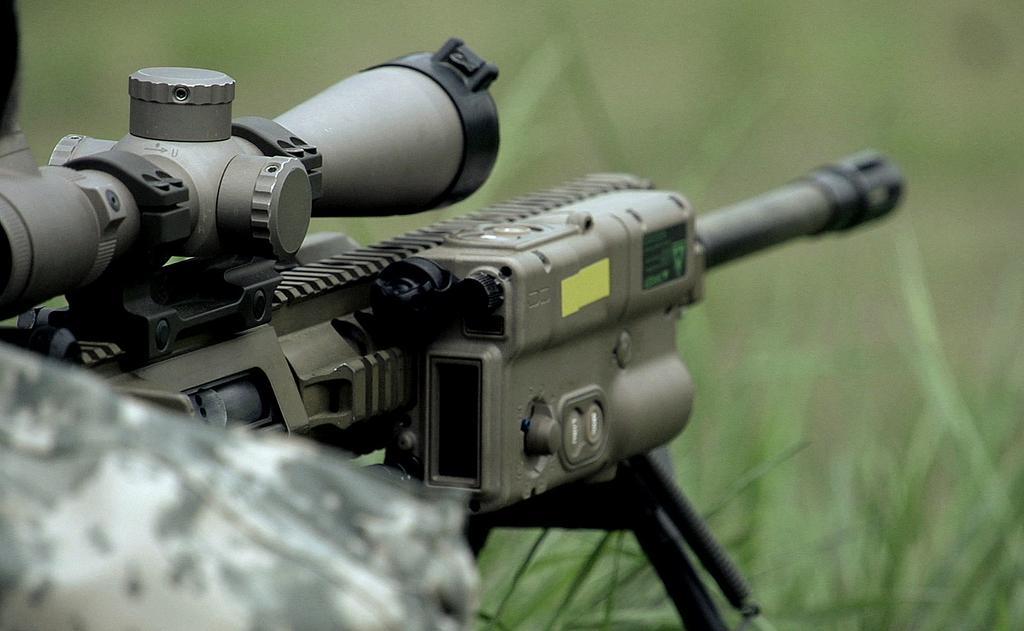Describe this image in one or two sentences. In this image we can see a gun on a stand. In the background the image is blur. At the bottom we can see the grass. On the left side we can see person's shoulder. 